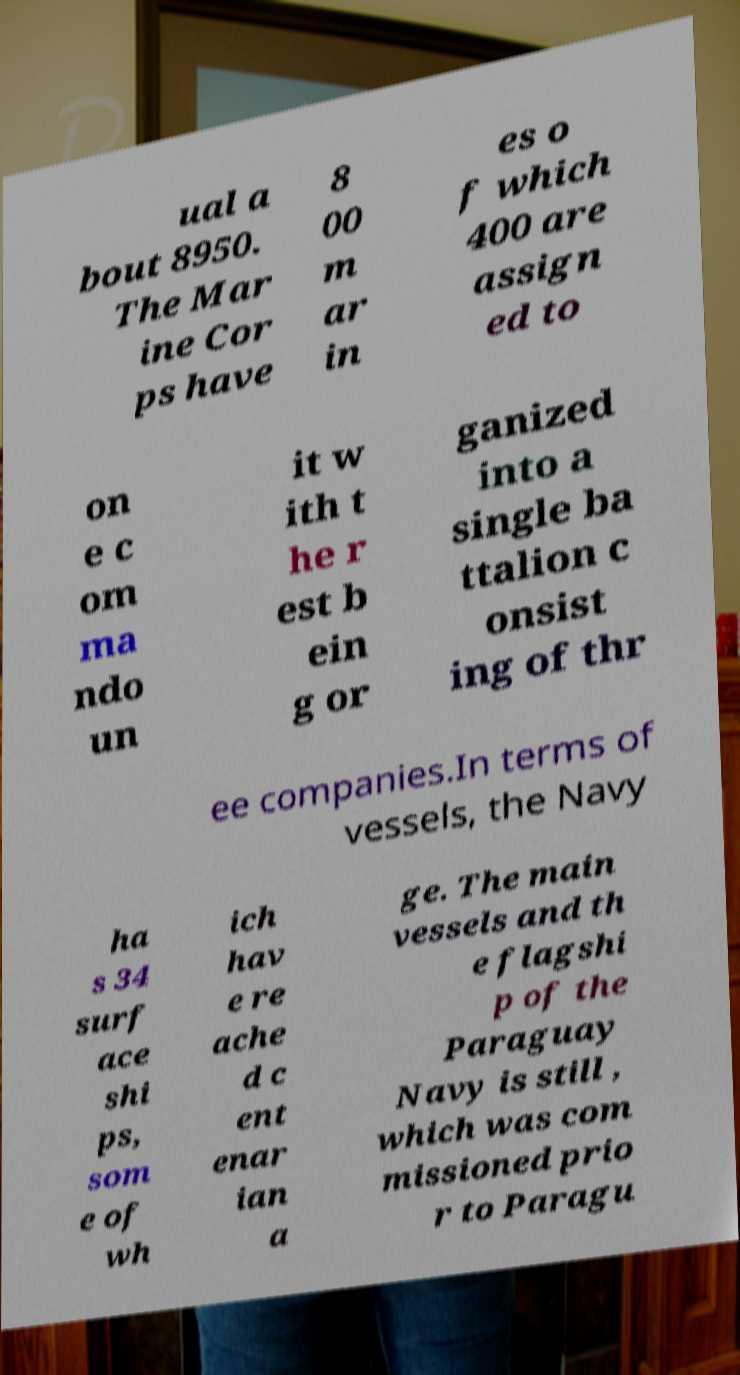I need the written content from this picture converted into text. Can you do that? ual a bout 8950. The Mar ine Cor ps have 8 00 m ar in es o f which 400 are assign ed to on e c om ma ndo un it w ith t he r est b ein g or ganized into a single ba ttalion c onsist ing of thr ee companies.In terms of vessels, the Navy ha s 34 surf ace shi ps, som e of wh ich hav e re ache d c ent enar ian a ge. The main vessels and th e flagshi p of the Paraguay Navy is still , which was com missioned prio r to Paragu 